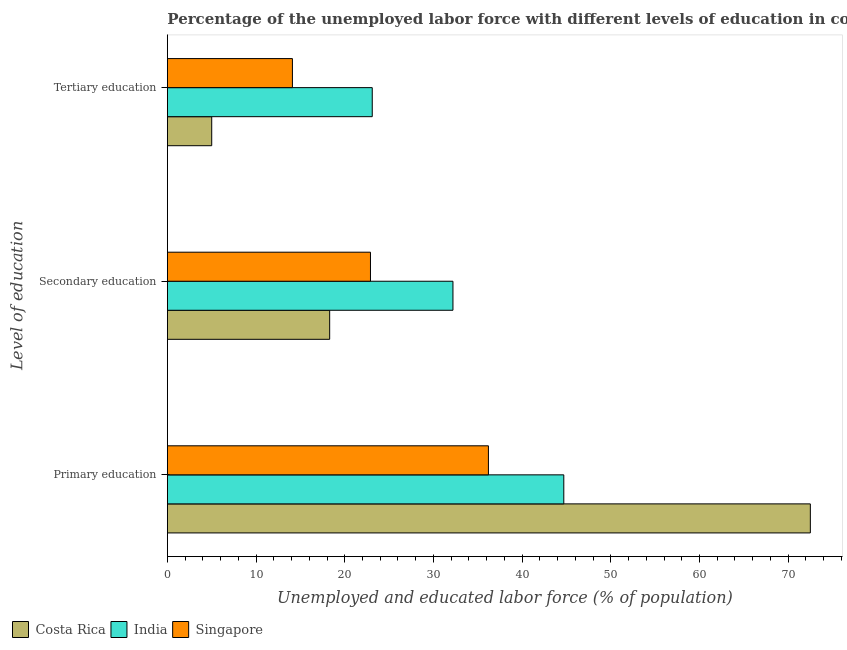Are the number of bars per tick equal to the number of legend labels?
Offer a very short reply. Yes. Are the number of bars on each tick of the Y-axis equal?
Provide a short and direct response. Yes. How many bars are there on the 2nd tick from the top?
Keep it short and to the point. 3. How many bars are there on the 2nd tick from the bottom?
Provide a short and direct response. 3. What is the percentage of labor force who received secondary education in Singapore?
Keep it short and to the point. 22.9. Across all countries, what is the maximum percentage of labor force who received tertiary education?
Give a very brief answer. 23.1. Across all countries, what is the minimum percentage of labor force who received primary education?
Your response must be concise. 36.2. In which country was the percentage of labor force who received primary education maximum?
Your answer should be very brief. Costa Rica. In which country was the percentage of labor force who received primary education minimum?
Offer a very short reply. Singapore. What is the total percentage of labor force who received secondary education in the graph?
Ensure brevity in your answer.  73.4. What is the difference between the percentage of labor force who received secondary education in Singapore and that in India?
Make the answer very short. -9.3. What is the difference between the percentage of labor force who received secondary education in India and the percentage of labor force who received tertiary education in Costa Rica?
Give a very brief answer. 27.2. What is the average percentage of labor force who received tertiary education per country?
Provide a succinct answer. 14.07. What is the difference between the percentage of labor force who received tertiary education and percentage of labor force who received secondary education in Costa Rica?
Offer a terse response. -13.3. In how many countries, is the percentage of labor force who received secondary education greater than 54 %?
Keep it short and to the point. 0. What is the ratio of the percentage of labor force who received primary education in India to that in Costa Rica?
Your answer should be very brief. 0.62. What is the difference between the highest and the second highest percentage of labor force who received tertiary education?
Give a very brief answer. 9. What is the difference between the highest and the lowest percentage of labor force who received tertiary education?
Ensure brevity in your answer.  18.1. In how many countries, is the percentage of labor force who received tertiary education greater than the average percentage of labor force who received tertiary education taken over all countries?
Give a very brief answer. 2. Is the sum of the percentage of labor force who received tertiary education in India and Costa Rica greater than the maximum percentage of labor force who received primary education across all countries?
Offer a terse response. No. What does the 1st bar from the top in Tertiary education represents?
Offer a very short reply. Singapore. What does the 2nd bar from the bottom in Tertiary education represents?
Ensure brevity in your answer.  India. Is it the case that in every country, the sum of the percentage of labor force who received primary education and percentage of labor force who received secondary education is greater than the percentage of labor force who received tertiary education?
Offer a very short reply. Yes. How many countries are there in the graph?
Your answer should be very brief. 3. Are the values on the major ticks of X-axis written in scientific E-notation?
Provide a short and direct response. No. Does the graph contain any zero values?
Make the answer very short. No. Where does the legend appear in the graph?
Make the answer very short. Bottom left. How are the legend labels stacked?
Your response must be concise. Horizontal. What is the title of the graph?
Provide a succinct answer. Percentage of the unemployed labor force with different levels of education in countries. What is the label or title of the X-axis?
Ensure brevity in your answer.  Unemployed and educated labor force (% of population). What is the label or title of the Y-axis?
Provide a succinct answer. Level of education. What is the Unemployed and educated labor force (% of population) in Costa Rica in Primary education?
Provide a short and direct response. 72.5. What is the Unemployed and educated labor force (% of population) of India in Primary education?
Your answer should be very brief. 44.7. What is the Unemployed and educated labor force (% of population) in Singapore in Primary education?
Give a very brief answer. 36.2. What is the Unemployed and educated labor force (% of population) of Costa Rica in Secondary education?
Offer a terse response. 18.3. What is the Unemployed and educated labor force (% of population) in India in Secondary education?
Ensure brevity in your answer.  32.2. What is the Unemployed and educated labor force (% of population) in Singapore in Secondary education?
Offer a terse response. 22.9. What is the Unemployed and educated labor force (% of population) of India in Tertiary education?
Your response must be concise. 23.1. What is the Unemployed and educated labor force (% of population) in Singapore in Tertiary education?
Your answer should be compact. 14.1. Across all Level of education, what is the maximum Unemployed and educated labor force (% of population) in Costa Rica?
Give a very brief answer. 72.5. Across all Level of education, what is the maximum Unemployed and educated labor force (% of population) in India?
Ensure brevity in your answer.  44.7. Across all Level of education, what is the maximum Unemployed and educated labor force (% of population) of Singapore?
Provide a short and direct response. 36.2. Across all Level of education, what is the minimum Unemployed and educated labor force (% of population) in Costa Rica?
Your answer should be very brief. 5. Across all Level of education, what is the minimum Unemployed and educated labor force (% of population) in India?
Offer a very short reply. 23.1. Across all Level of education, what is the minimum Unemployed and educated labor force (% of population) in Singapore?
Your answer should be very brief. 14.1. What is the total Unemployed and educated labor force (% of population) of Costa Rica in the graph?
Provide a succinct answer. 95.8. What is the total Unemployed and educated labor force (% of population) in Singapore in the graph?
Give a very brief answer. 73.2. What is the difference between the Unemployed and educated labor force (% of population) of Costa Rica in Primary education and that in Secondary education?
Your response must be concise. 54.2. What is the difference between the Unemployed and educated labor force (% of population) of India in Primary education and that in Secondary education?
Your response must be concise. 12.5. What is the difference between the Unemployed and educated labor force (% of population) of Singapore in Primary education and that in Secondary education?
Offer a terse response. 13.3. What is the difference between the Unemployed and educated labor force (% of population) of Costa Rica in Primary education and that in Tertiary education?
Your response must be concise. 67.5. What is the difference between the Unemployed and educated labor force (% of population) in India in Primary education and that in Tertiary education?
Offer a terse response. 21.6. What is the difference between the Unemployed and educated labor force (% of population) in Singapore in Primary education and that in Tertiary education?
Provide a succinct answer. 22.1. What is the difference between the Unemployed and educated labor force (% of population) of India in Secondary education and that in Tertiary education?
Provide a succinct answer. 9.1. What is the difference between the Unemployed and educated labor force (% of population) of Singapore in Secondary education and that in Tertiary education?
Offer a terse response. 8.8. What is the difference between the Unemployed and educated labor force (% of population) of Costa Rica in Primary education and the Unemployed and educated labor force (% of population) of India in Secondary education?
Provide a succinct answer. 40.3. What is the difference between the Unemployed and educated labor force (% of population) of Costa Rica in Primary education and the Unemployed and educated labor force (% of population) of Singapore in Secondary education?
Your response must be concise. 49.6. What is the difference between the Unemployed and educated labor force (% of population) in India in Primary education and the Unemployed and educated labor force (% of population) in Singapore in Secondary education?
Make the answer very short. 21.8. What is the difference between the Unemployed and educated labor force (% of population) of Costa Rica in Primary education and the Unemployed and educated labor force (% of population) of India in Tertiary education?
Give a very brief answer. 49.4. What is the difference between the Unemployed and educated labor force (% of population) of Costa Rica in Primary education and the Unemployed and educated labor force (% of population) of Singapore in Tertiary education?
Your response must be concise. 58.4. What is the difference between the Unemployed and educated labor force (% of population) of India in Primary education and the Unemployed and educated labor force (% of population) of Singapore in Tertiary education?
Your answer should be compact. 30.6. What is the difference between the Unemployed and educated labor force (% of population) of Costa Rica in Secondary education and the Unemployed and educated labor force (% of population) of India in Tertiary education?
Your answer should be compact. -4.8. What is the average Unemployed and educated labor force (% of population) of Costa Rica per Level of education?
Your answer should be compact. 31.93. What is the average Unemployed and educated labor force (% of population) of India per Level of education?
Ensure brevity in your answer.  33.33. What is the average Unemployed and educated labor force (% of population) of Singapore per Level of education?
Keep it short and to the point. 24.4. What is the difference between the Unemployed and educated labor force (% of population) in Costa Rica and Unemployed and educated labor force (% of population) in India in Primary education?
Your answer should be very brief. 27.8. What is the difference between the Unemployed and educated labor force (% of population) of Costa Rica and Unemployed and educated labor force (% of population) of Singapore in Primary education?
Ensure brevity in your answer.  36.3. What is the difference between the Unemployed and educated labor force (% of population) in Costa Rica and Unemployed and educated labor force (% of population) in India in Secondary education?
Your answer should be compact. -13.9. What is the difference between the Unemployed and educated labor force (% of population) in India and Unemployed and educated labor force (% of population) in Singapore in Secondary education?
Make the answer very short. 9.3. What is the difference between the Unemployed and educated labor force (% of population) of Costa Rica and Unemployed and educated labor force (% of population) of India in Tertiary education?
Keep it short and to the point. -18.1. What is the difference between the Unemployed and educated labor force (% of population) of Costa Rica and Unemployed and educated labor force (% of population) of Singapore in Tertiary education?
Offer a very short reply. -9.1. What is the ratio of the Unemployed and educated labor force (% of population) of Costa Rica in Primary education to that in Secondary education?
Provide a short and direct response. 3.96. What is the ratio of the Unemployed and educated labor force (% of population) in India in Primary education to that in Secondary education?
Ensure brevity in your answer.  1.39. What is the ratio of the Unemployed and educated labor force (% of population) in Singapore in Primary education to that in Secondary education?
Offer a very short reply. 1.58. What is the ratio of the Unemployed and educated labor force (% of population) in India in Primary education to that in Tertiary education?
Give a very brief answer. 1.94. What is the ratio of the Unemployed and educated labor force (% of population) of Singapore in Primary education to that in Tertiary education?
Give a very brief answer. 2.57. What is the ratio of the Unemployed and educated labor force (% of population) of Costa Rica in Secondary education to that in Tertiary education?
Your answer should be very brief. 3.66. What is the ratio of the Unemployed and educated labor force (% of population) of India in Secondary education to that in Tertiary education?
Provide a succinct answer. 1.39. What is the ratio of the Unemployed and educated labor force (% of population) in Singapore in Secondary education to that in Tertiary education?
Give a very brief answer. 1.62. What is the difference between the highest and the second highest Unemployed and educated labor force (% of population) of Costa Rica?
Your answer should be compact. 54.2. What is the difference between the highest and the second highest Unemployed and educated labor force (% of population) of Singapore?
Provide a short and direct response. 13.3. What is the difference between the highest and the lowest Unemployed and educated labor force (% of population) of Costa Rica?
Offer a very short reply. 67.5. What is the difference between the highest and the lowest Unemployed and educated labor force (% of population) in India?
Your response must be concise. 21.6. What is the difference between the highest and the lowest Unemployed and educated labor force (% of population) of Singapore?
Offer a very short reply. 22.1. 